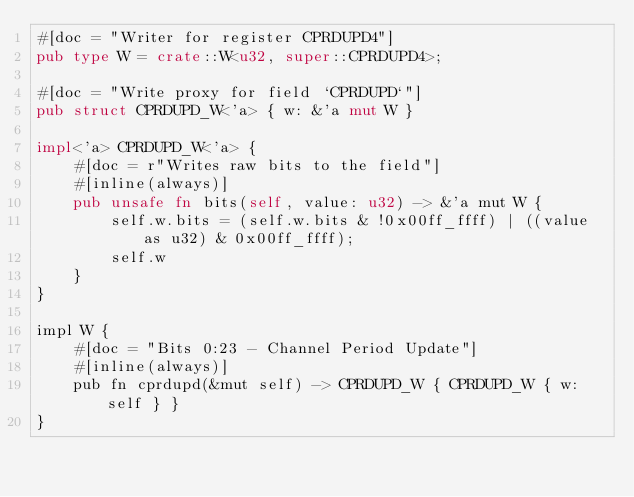Convert code to text. <code><loc_0><loc_0><loc_500><loc_500><_Rust_>#[doc = "Writer for register CPRDUPD4"]
pub type W = crate::W<u32, super::CPRDUPD4>;

#[doc = "Write proxy for field `CPRDUPD`"]
pub struct CPRDUPD_W<'a> { w: &'a mut W }

impl<'a> CPRDUPD_W<'a> {
    #[doc = r"Writes raw bits to the field"]
    #[inline(always)]
    pub unsafe fn bits(self, value: u32) -> &'a mut W {
        self.w.bits = (self.w.bits & !0x00ff_ffff) | ((value as u32) & 0x00ff_ffff);
        self.w
    }
}

impl W {
    #[doc = "Bits 0:23 - Channel Period Update"]
    #[inline(always)]
    pub fn cprdupd(&mut self) -> CPRDUPD_W { CPRDUPD_W { w: self } }
}</code> 